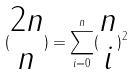Convert formula to latex. <formula><loc_0><loc_0><loc_500><loc_500>( \begin{matrix} 2 n \\ n \end{matrix} ) = \sum _ { i = 0 } ^ { n } ( \begin{matrix} n \\ i \end{matrix} ) ^ { 2 }</formula> 